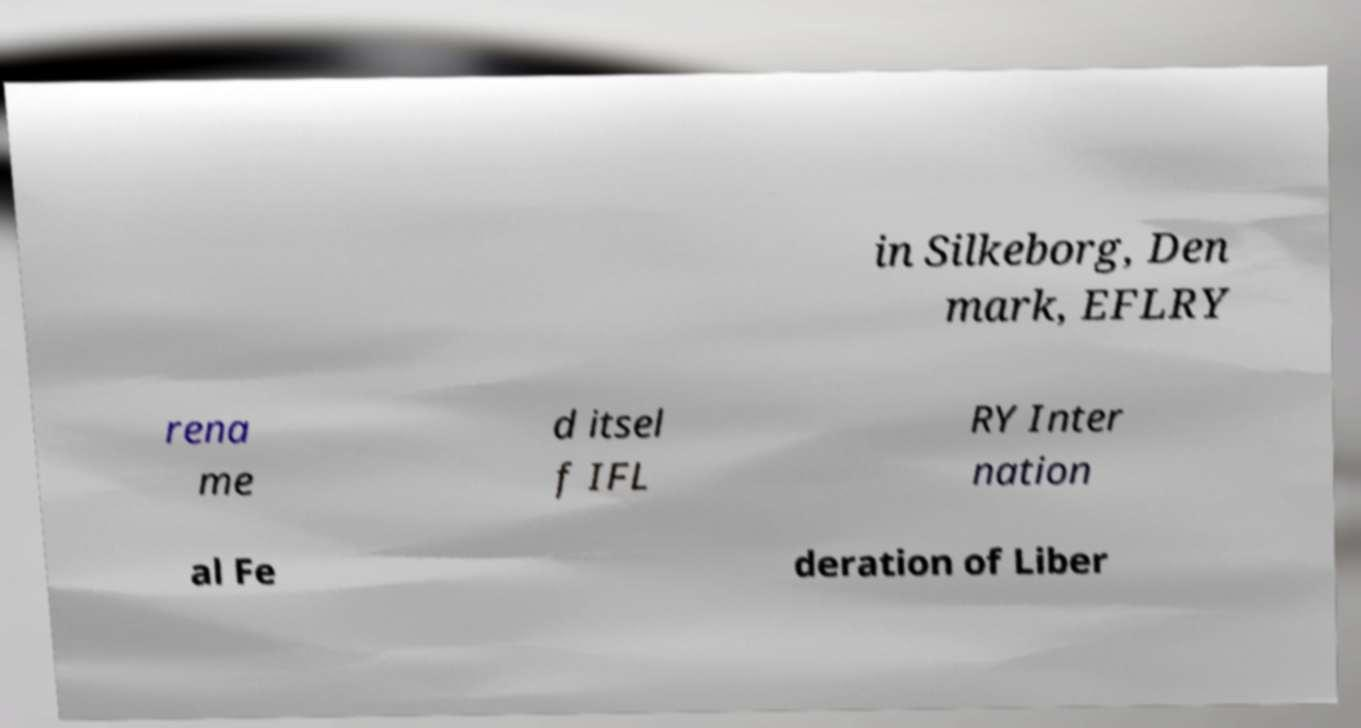Could you assist in decoding the text presented in this image and type it out clearly? in Silkeborg, Den mark, EFLRY rena me d itsel f IFL RY Inter nation al Fe deration of Liber 